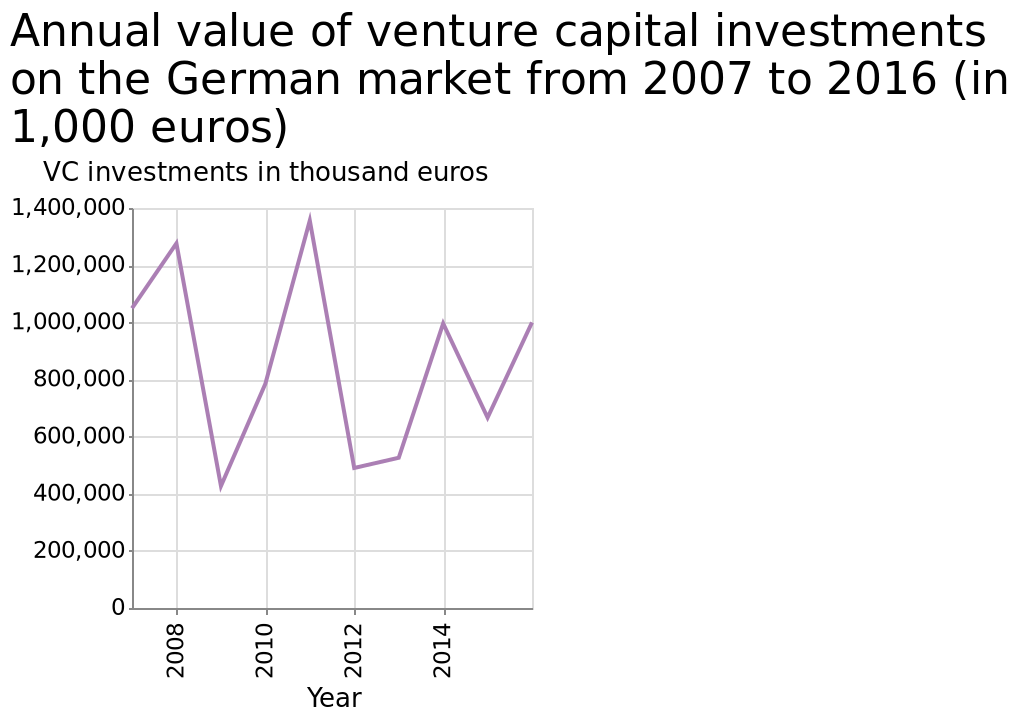<image>
please enumerates aspects of the construction of the chart Here a line chart is named Annual value of venture capital investments on the German market from 2007 to 2016 (in 1,000 euros). Along the y-axis, VC investments in thousand euros is defined on a linear scale with a minimum of 0 and a maximum of 1,400,000. On the x-axis, Year is defined as a linear scale with a minimum of 2008 and a maximum of 2014. Was the investment between 2020 and 2012 significant?  Yes, the investment between 2020 and 2012 was staggering, reaching 1,400,000. 